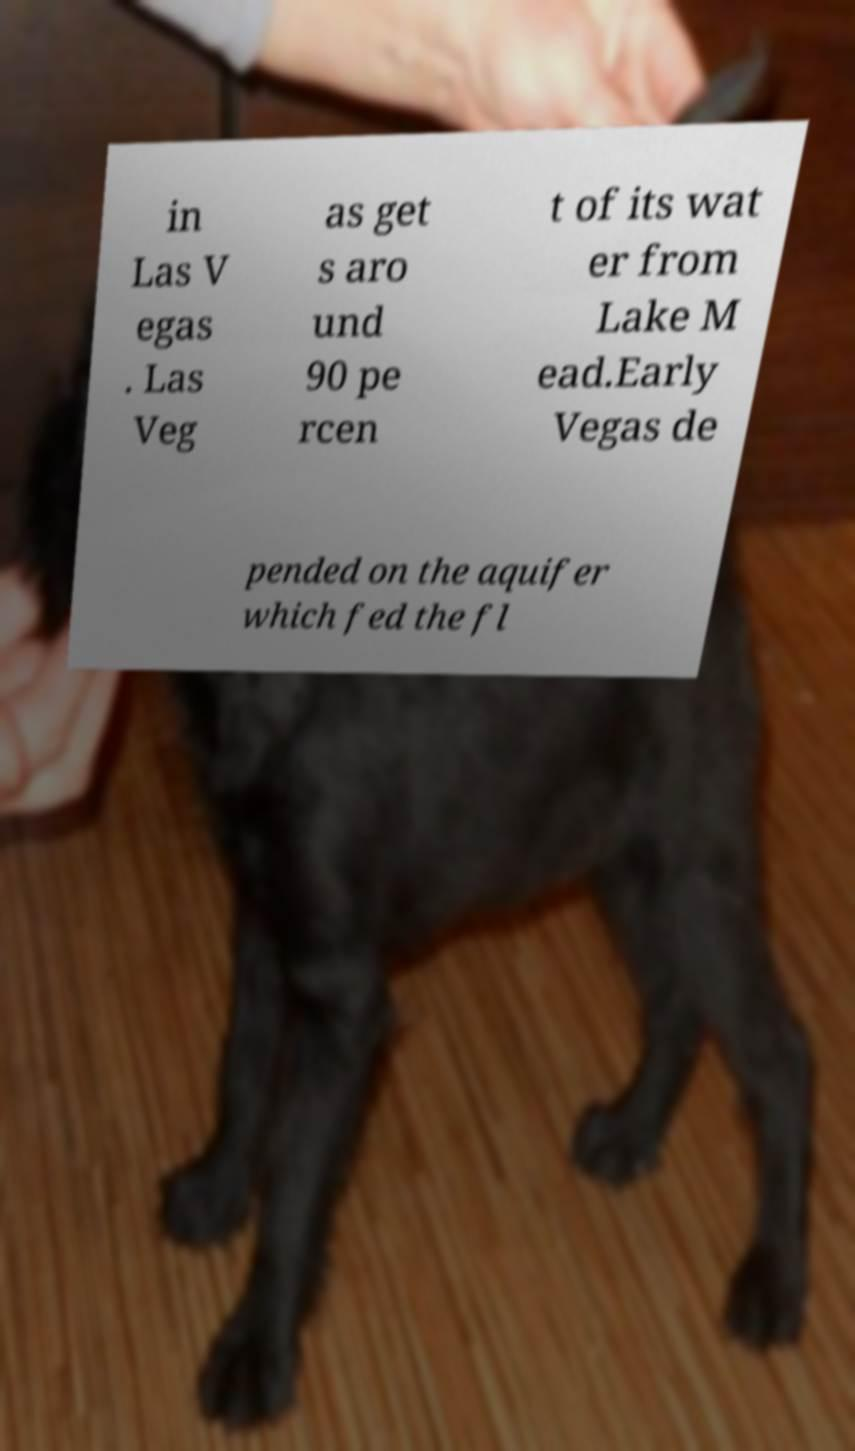I need the written content from this picture converted into text. Can you do that? in Las V egas . Las Veg as get s aro und 90 pe rcen t of its wat er from Lake M ead.Early Vegas de pended on the aquifer which fed the fl 